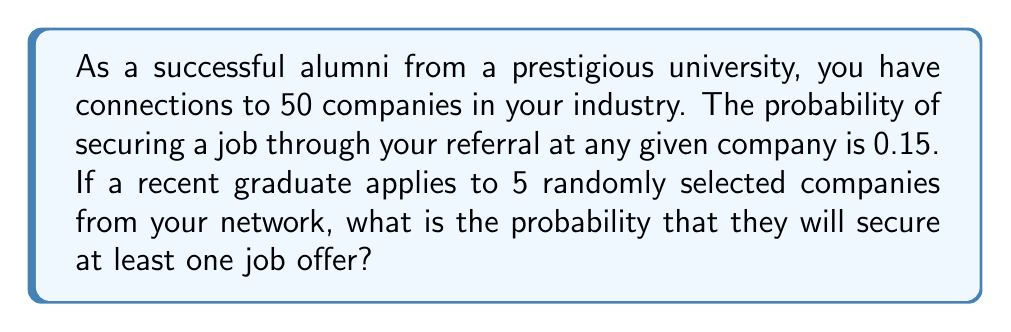Help me with this question. Let's approach this step-by-step:

1) First, we need to calculate the probability of not getting a job offer from a single company. If the probability of success is 0.15, then the probability of failure is:

   $1 - 0.15 = 0.85$

2) Now, we need to calculate the probability of not getting a job offer from all 5 companies. Since the selections are random and independent, we can multiply these probabilities:

   $(0.85)^5 = 0.4437$

3) This 0.4437 represents the probability of failing to get a job offer from all 5 companies. Therefore, the probability of getting at least one job offer is the complement of this:

   $1 - (0.85)^5 = 1 - 0.4437 = 0.5563$

4) We can express this as a percentage:

   $0.5563 \times 100\% = 55.63\%$

This problem is an application of the complementary event principle in probability theory. Instead of calculating the probability of at least one success directly, which would involve considering multiple cases, we calculate the probability of no successes and subtract it from 1.

The formula used here is:

$$P(\text{at least one success}) = 1 - P(\text{all failures})$$

Where $P(\text{all failures}) = (1-p)^n$, with $p$ being the probability of success on a single trial and $n$ being the number of trials.
Answer: The probability that the recent graduate will secure at least one job offer is approximately 0.5563 or 55.63%. 